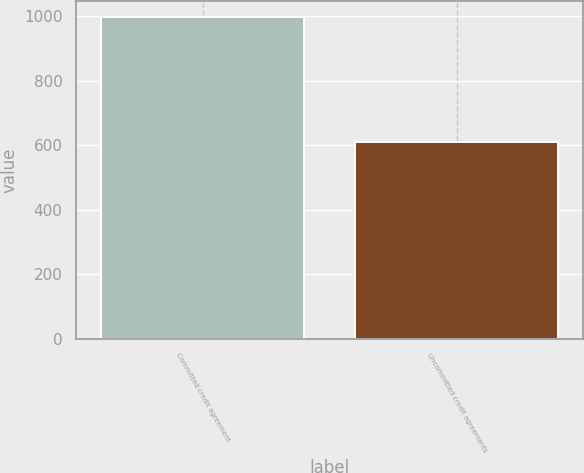<chart> <loc_0><loc_0><loc_500><loc_500><bar_chart><fcel>Committed credit agreement<fcel>Uncommitted credit agreements<nl><fcel>996.3<fcel>610.5<nl></chart> 